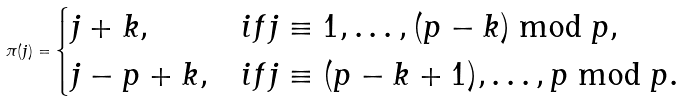Convert formula to latex. <formula><loc_0><loc_0><loc_500><loc_500>\pi ( j ) = \begin{cases} j + k , & i f j \equiv 1 , \dots , ( p - k ) \bmod p , \\ j - p + k , & i f j \equiv ( p - k + 1 ) , \dots , p \bmod p . \end{cases}</formula> 